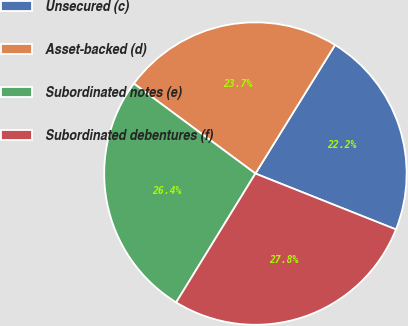<chart> <loc_0><loc_0><loc_500><loc_500><pie_chart><fcel>Unsecured (c)<fcel>Asset-backed (d)<fcel>Subordinated notes (e)<fcel>Subordinated debentures (f)<nl><fcel>22.2%<fcel>23.68%<fcel>26.36%<fcel>27.75%<nl></chart> 